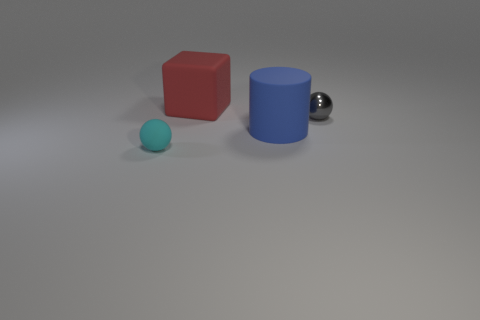Is there any other thing that has the same shape as the blue matte thing?
Offer a very short reply. No. What size is the rubber thing right of the large object on the left side of the matte cylinder?
Offer a terse response. Large. What number of small things are either cyan rubber balls or gray balls?
Your answer should be very brief. 2. How many other objects are there of the same color as the shiny sphere?
Make the answer very short. 0. Do the sphere that is right of the small matte ball and the cylinder in front of the gray object have the same size?
Provide a succinct answer. No. Is the small cyan sphere made of the same material as the ball that is to the right of the blue thing?
Keep it short and to the point. No. Is the number of tiny gray metal objects that are behind the gray shiny ball greater than the number of things that are in front of the cylinder?
Your answer should be very brief. No. There is a object in front of the large blue rubber object that is on the left side of the gray sphere; what is its color?
Your answer should be very brief. Cyan. What number of cylinders are red rubber things or blue matte objects?
Your answer should be compact. 1. How many small things are behind the tiny rubber object and to the left of the big red block?
Provide a short and direct response. 0. 